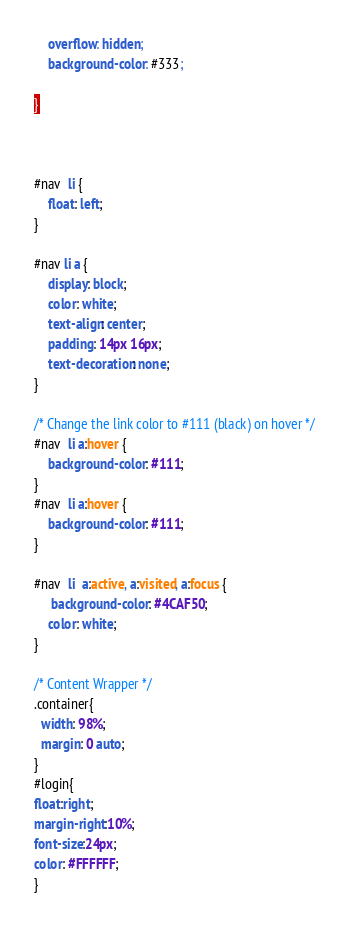<code> <loc_0><loc_0><loc_500><loc_500><_CSS_>    overflow: hidden;
    background-color: #333;
	
}



#nav  li {
    float: left;
}

#nav li a {
    display: block;
    color: white;
    text-align: center;
    padding: 14px 16px;
    text-decoration: none;
}

/* Change the link color to #111 (black) on hover */
#nav  li a:hover {
    background-color: #111;
}
#nav  li a:hover {
    background-color: #111;
}

#nav  li  a:active, a:visited, a:focus {
     background-color: #4CAF50;
    color: white;
}

/* Content Wrapper */
.container{
  width: 98%;
  margin: 0 auto;
}
#login{
float:right;
margin-right:10%;
font-size:24px;
color: #FFFFFF;
}</code> 